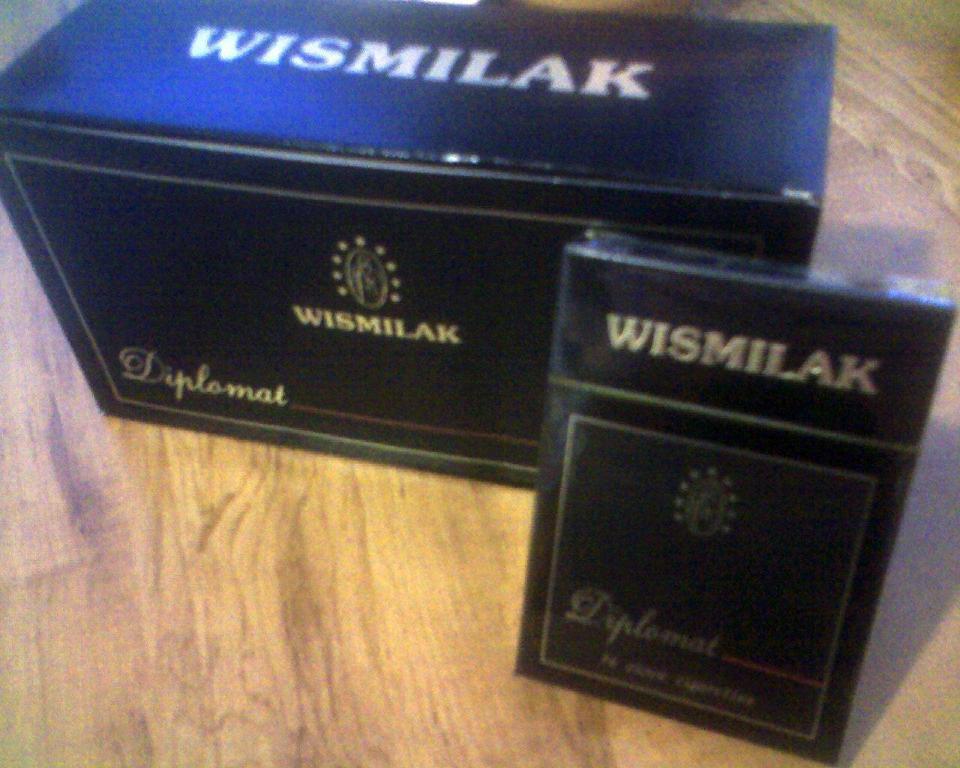What is the name of this product?
Your answer should be compact. Wismilak. 